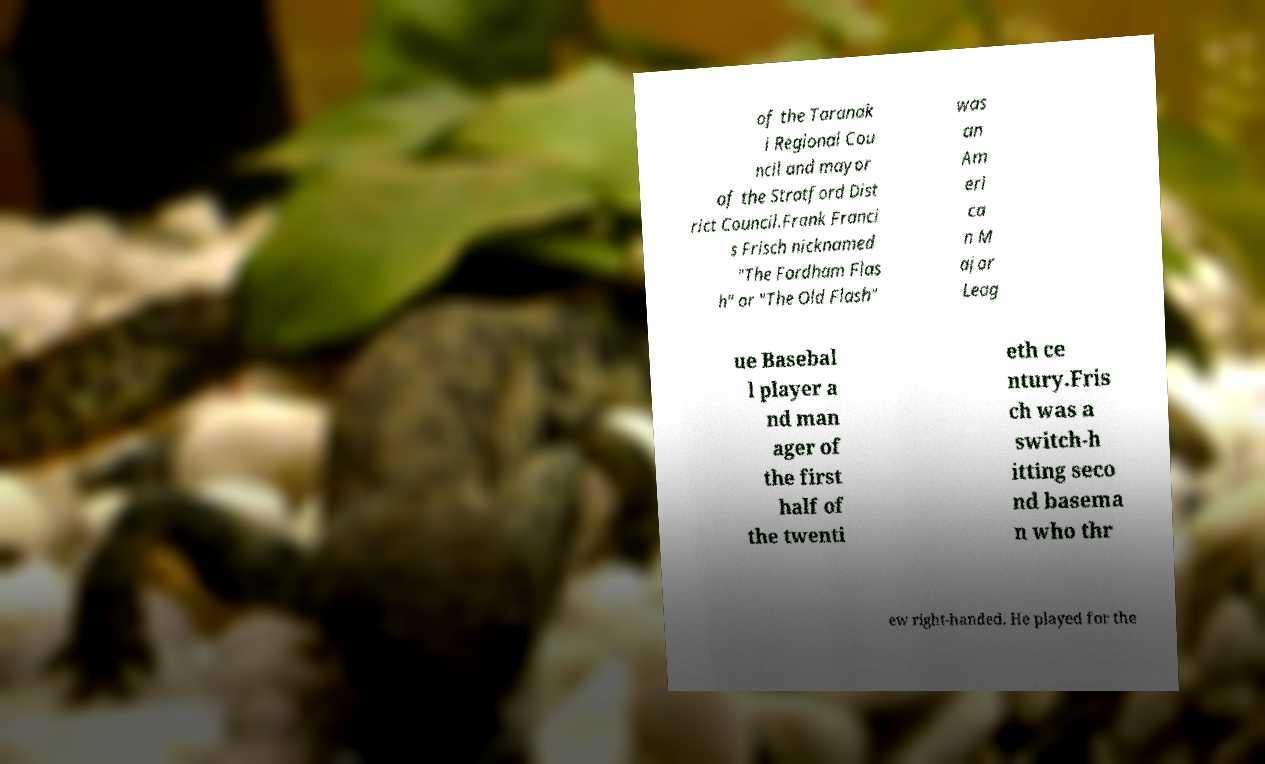There's text embedded in this image that I need extracted. Can you transcribe it verbatim? of the Taranak i Regional Cou ncil and mayor of the Stratford Dist rict Council.Frank Franci s Frisch nicknamed "The Fordham Flas h" or "The Old Flash" was an Am eri ca n M ajor Leag ue Basebal l player a nd man ager of the first half of the twenti eth ce ntury.Fris ch was a switch-h itting seco nd basema n who thr ew right-handed. He played for the 